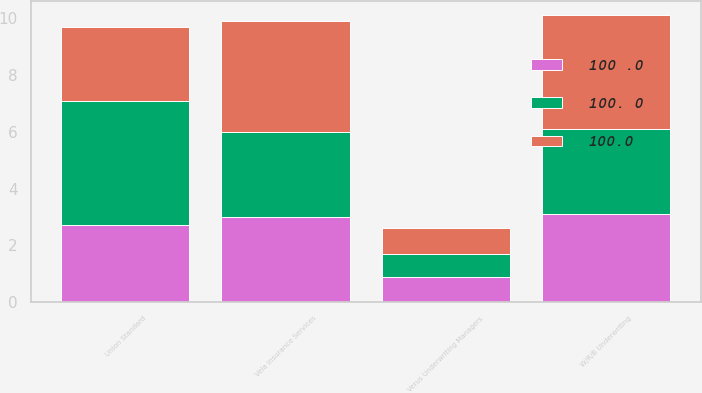Convert chart. <chart><loc_0><loc_0><loc_500><loc_500><stacked_bar_chart><ecel><fcel>Union Standard<fcel>Vela Insurance Services<fcel>Verus Underwriting Managers<fcel>W/R/B Underwriting<nl><fcel>100 .0<fcel>2.7<fcel>3<fcel>0.9<fcel>3.1<nl><fcel>100.0<fcel>2.6<fcel>3.9<fcel>0.9<fcel>4<nl><fcel>100. 0<fcel>4.4<fcel>3<fcel>0.8<fcel>3<nl></chart> 